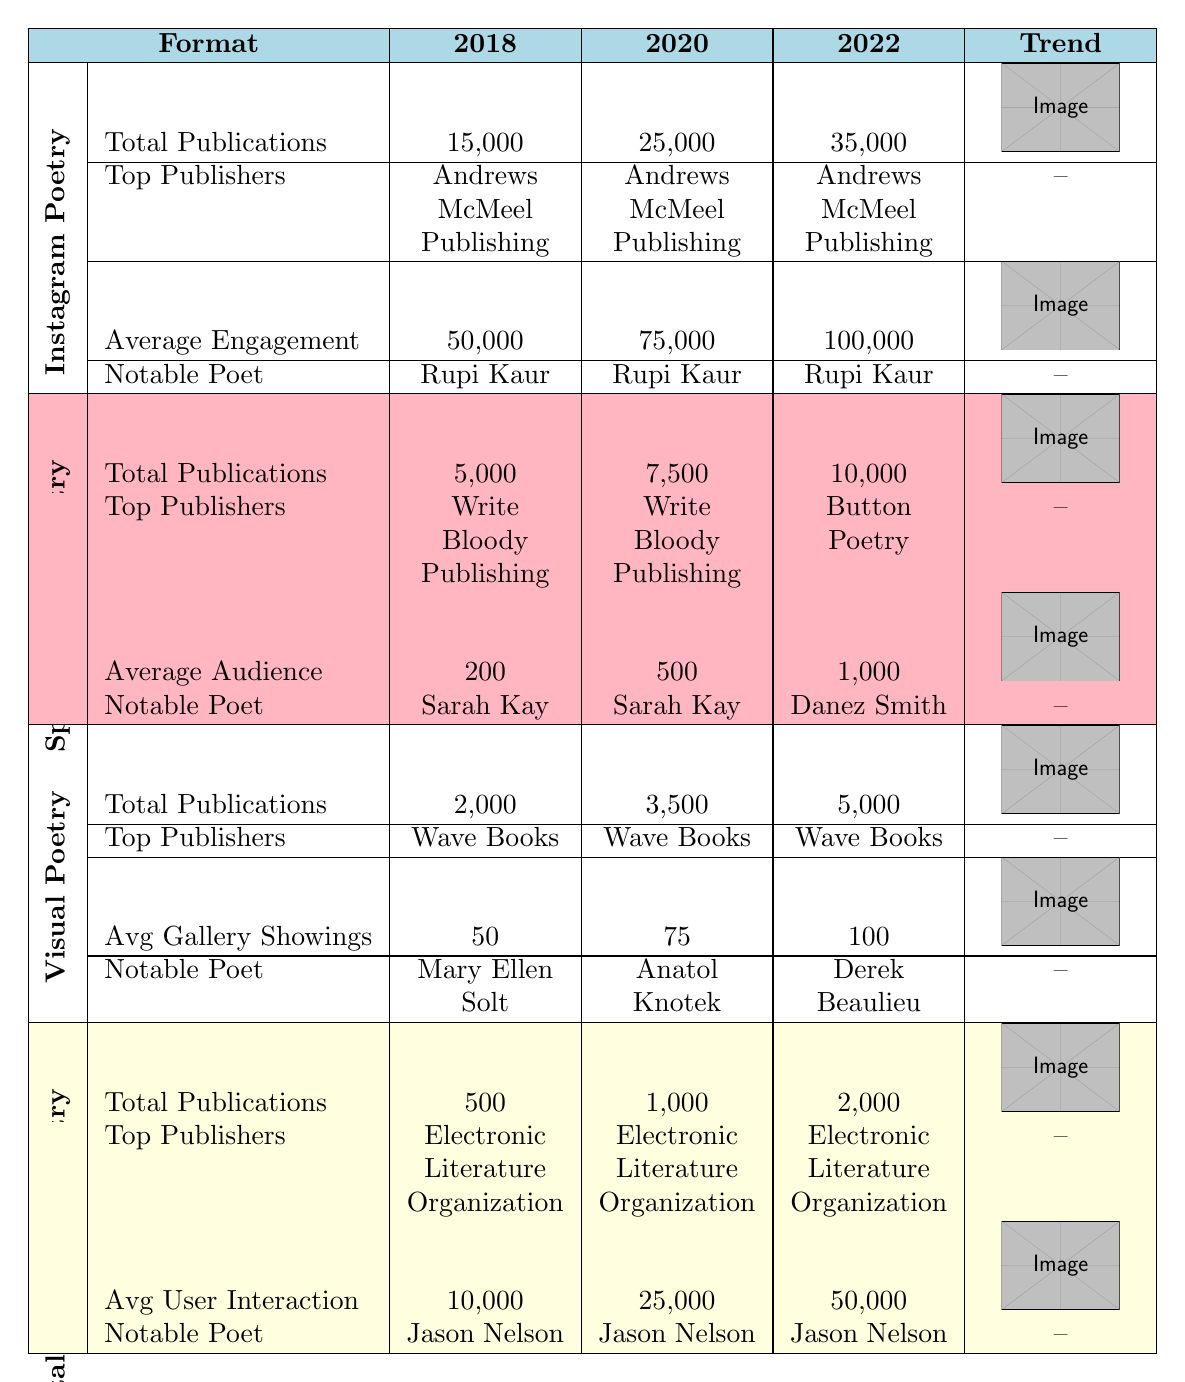What is the total number of publications for Instagram Poetry in 2020? The table shows that the total publications for Instagram Poetry in 2020 is 25,000.
Answer: 25,000 Which notable poet is consistently listed for Instagram Poetry across all years? Reviewing the table, Rupi Kaur is noted as a prominent poet for Instagram Poetry in the years 2018, 2020, and 2022.
Answer: Rupi Kaur What is the average user interaction for Digital Interactive Poetry in 2022? The table indicates that the average user interaction for Digital Interactive Poetry in 2022 is 50,000.
Answer: 50,000 Which format has the highest total publications in 2022? By comparing total publications in 2022, Instagram Poetry has 35,000, Spoken Word Poetry has 10,000, Visual Poetry has 5,000, and Digital Interactive Poetry has 2,000. Instagram Poetry has the highest total.
Answer: Instagram Poetry What is the trend in total publications for Spoken Word Poetry from 2018 to 2022? For Spoken Word Poetry, the total publications increased from 5,000 in 2018 to 7,500 in 2020, and then to 10,000 in 2022. This shows a consistent upward trend.
Answer: Increasing How much did the average engagement for Instagram Poetry increase from 2020 to 2022? The average engagement for Instagram Poetry in 2020 is 75,000 and in 2022 is 100,000. The increase is 100,000 - 75,000 = 25,000.
Answer: 25,000 Are Write Bloody Publishing and Button Poetry the top publishers for Spoken Word Poetry in all years? The table lists Write Bloody Publishing and Button Poetry as top publishers for 2018 and 2020, but for 2022, Button Poetry and Coffee House Press are top publishers instead of Write Bloody Publishing.
Answer: No Which poem format had the lowest total publications in 2018? Checking the total publications, Digital Interactive Poetry had only 500 publications in 2018, which is the lowest compared to other formats.
Answer: Digital Interactive Poetry What is the average annual increase in total publications for Visual Poetry from 2018 to 2022? Total publications for Visual Poetry are 2,000 in 2018, 3,500 in 2020, and 5,000 in 2022. The increases are 3,500 - 2,000 = 1,500 from 2018 to 2020, and 5,000 - 3,500 = 1,500 from 2020 to 2022. The total increase is 1,500 + 1,500 = 3,000 over 4 years (2018 to 2022), so the average annual increase is 3,000 / 4 = 750.
Answer: 750 Identify the top publisher for Digital Interactive Poetry in all listed years. The table shows that the Electronic Literature Organization is the top publisher for Digital Interactive Poetry in 2018, 2020, and 2022.
Answer: Electronic Literature Organization What notable poets for Spoken Word Poetry have emerged in 2022 compared to previous years? In 2022, Danez Smith is noted as a prominent poet for Spoken Word Poetry, while Sarah Kay and Phil Kaye were notable in previous years. Comparing years reveals Danez Smith is a new entry for 2022.
Answer: New entry: Danez Smith 